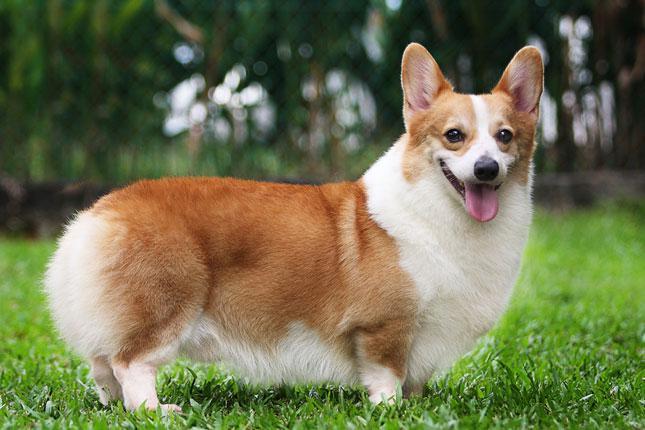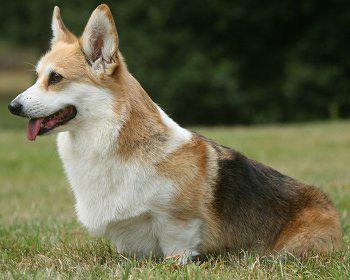The first image is the image on the left, the second image is the image on the right. Considering the images on both sides, is "An image shows a corgi with body turned leftward on a white background." valid? Answer yes or no. No. The first image is the image on the left, the second image is the image on the right. Given the left and right images, does the statement "There are two dogs with tongue sticking out." hold true? Answer yes or no. Yes. 